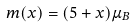Convert formula to latex. <formula><loc_0><loc_0><loc_500><loc_500>m ( x ) = ( 5 + x ) \mu _ { B }</formula> 